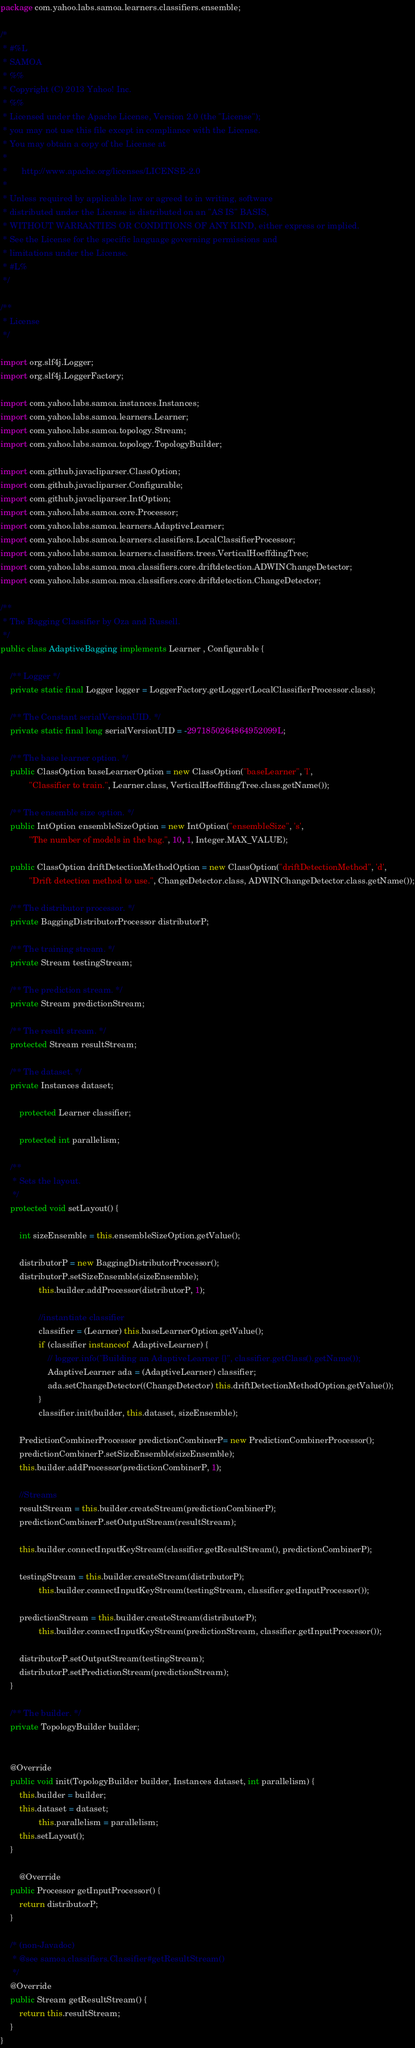Convert code to text. <code><loc_0><loc_0><loc_500><loc_500><_Java_>package com.yahoo.labs.samoa.learners.classifiers.ensemble;

/*
 * #%L
 * SAMOA
 * %%
 * Copyright (C) 2013 Yahoo! Inc.
 * %%
 * Licensed under the Apache License, Version 2.0 (the "License");
 * you may not use this file except in compliance with the License.
 * You may obtain a copy of the License at
 * 
 *      http://www.apache.org/licenses/LICENSE-2.0
 * 
 * Unless required by applicable law or agreed to in writing, software
 * distributed under the License is distributed on an "AS IS" BASIS,
 * WITHOUT WARRANTIES OR CONDITIONS OF ANY KIND, either express or implied.
 * See the License for the specific language governing permissions and
 * limitations under the License.
 * #L%
 */

/**
 * License
 */

import org.slf4j.Logger;
import org.slf4j.LoggerFactory;

import com.yahoo.labs.samoa.instances.Instances;
import com.yahoo.labs.samoa.learners.Learner;
import com.yahoo.labs.samoa.topology.Stream;
import com.yahoo.labs.samoa.topology.TopologyBuilder;

import com.github.javacliparser.ClassOption;
import com.github.javacliparser.Configurable;
import com.github.javacliparser.IntOption;
import com.yahoo.labs.samoa.core.Processor;
import com.yahoo.labs.samoa.learners.AdaptiveLearner;
import com.yahoo.labs.samoa.learners.classifiers.LocalClassifierProcessor;
import com.yahoo.labs.samoa.learners.classifiers.trees.VerticalHoeffdingTree;
import com.yahoo.labs.samoa.moa.classifiers.core.driftdetection.ADWINChangeDetector;
import com.yahoo.labs.samoa.moa.classifiers.core.driftdetection.ChangeDetector;

/**
 * The Bagging Classifier by Oza and Russell.
 */
public class AdaptiveBagging implements Learner , Configurable {
    
    /** Logger */
    private static final Logger logger = LoggerFactory.getLogger(LocalClassifierProcessor.class);

	/** The Constant serialVersionUID. */
	private static final long serialVersionUID = -2971850264864952099L;
	
	/** The base learner option. */
	public ClassOption baseLearnerOption = new ClassOption("baseLearner", 'l',
			"Classifier to train.", Learner.class, VerticalHoeffdingTree.class.getName());

	/** The ensemble size option. */
	public IntOption ensembleSizeOption = new IntOption("ensembleSize", 's',
			"The number of models in the bag.", 10, 1, Integer.MAX_VALUE);

    public ClassOption driftDetectionMethodOption = new ClassOption("driftDetectionMethod", 'd',
            "Drift detection method to use.", ChangeDetector.class, ADWINChangeDetector.class.getName());

	/** The distributor processor. */
	private BaggingDistributorProcessor distributorP;
	
	/** The training stream. */
	private Stream testingStream;
	
	/** The prediction stream. */
	private Stream predictionStream;
	
	/** The result stream. */
	protected Stream resultStream;
	
	/** The dataset. */
	private Instances dataset;
        
        protected Learner classifier;
        
        protected int parallelism;

	/**
	 * Sets the layout.
	 */
	protected void setLayout() {

		int sizeEnsemble = this.ensembleSizeOption.getValue();

		distributorP = new BaggingDistributorProcessor();
		distributorP.setSizeEnsemble(sizeEnsemble);
                this.builder.addProcessor(distributorP, 1);
		        
                //instantiate classifier 
                classifier = (Learner) this.baseLearnerOption.getValue();
                if (classifier instanceof AdaptiveLearner) {
                    // logger.info("Building an AdaptiveLearner {}", classifier.getClass().getName());
                    AdaptiveLearner ada = (AdaptiveLearner) classifier;
                    ada.setChangeDetector((ChangeDetector) this.driftDetectionMethodOption.getValue());
                }
                classifier.init(builder, this.dataset, sizeEnsemble);
        
		PredictionCombinerProcessor predictionCombinerP= new PredictionCombinerProcessor();
		predictionCombinerP.setSizeEnsemble(sizeEnsemble);
		this.builder.addProcessor(predictionCombinerP, 1);
		
		//Streams
		resultStream = this.builder.createStream(predictionCombinerP);
		predictionCombinerP.setOutputStream(resultStream);

 		this.builder.connectInputKeyStream(classifier.getResultStream(), predictionCombinerP);
		
		testingStream = this.builder.createStream(distributorP);
                this.builder.connectInputKeyStream(testingStream, classifier.getInputProcessor());
	
		predictionStream = this.builder.createStream(distributorP);		
                this.builder.connectInputKeyStream(predictionStream, classifier.getInputProcessor());
		
		distributorP.setOutputStream(testingStream);
		distributorP.setPredictionStream(predictionStream);
	}

	/** The builder. */
	private TopologyBuilder builder;
		
	
	@Override
	public void init(TopologyBuilder builder, Instances dataset, int parallelism) {
		this.builder = builder;
		this.dataset = dataset;
                this.parallelism = parallelism;
		this.setLayout();
	}

        @Override
	public Processor getInputProcessor() {
		return distributorP;
	}
        
	/* (non-Javadoc)
	 * @see samoa.classifiers.Classifier#getResultStream()
	 */
	@Override
	public Stream getResultStream() {
		return this.resultStream;
	}
}
</code> 